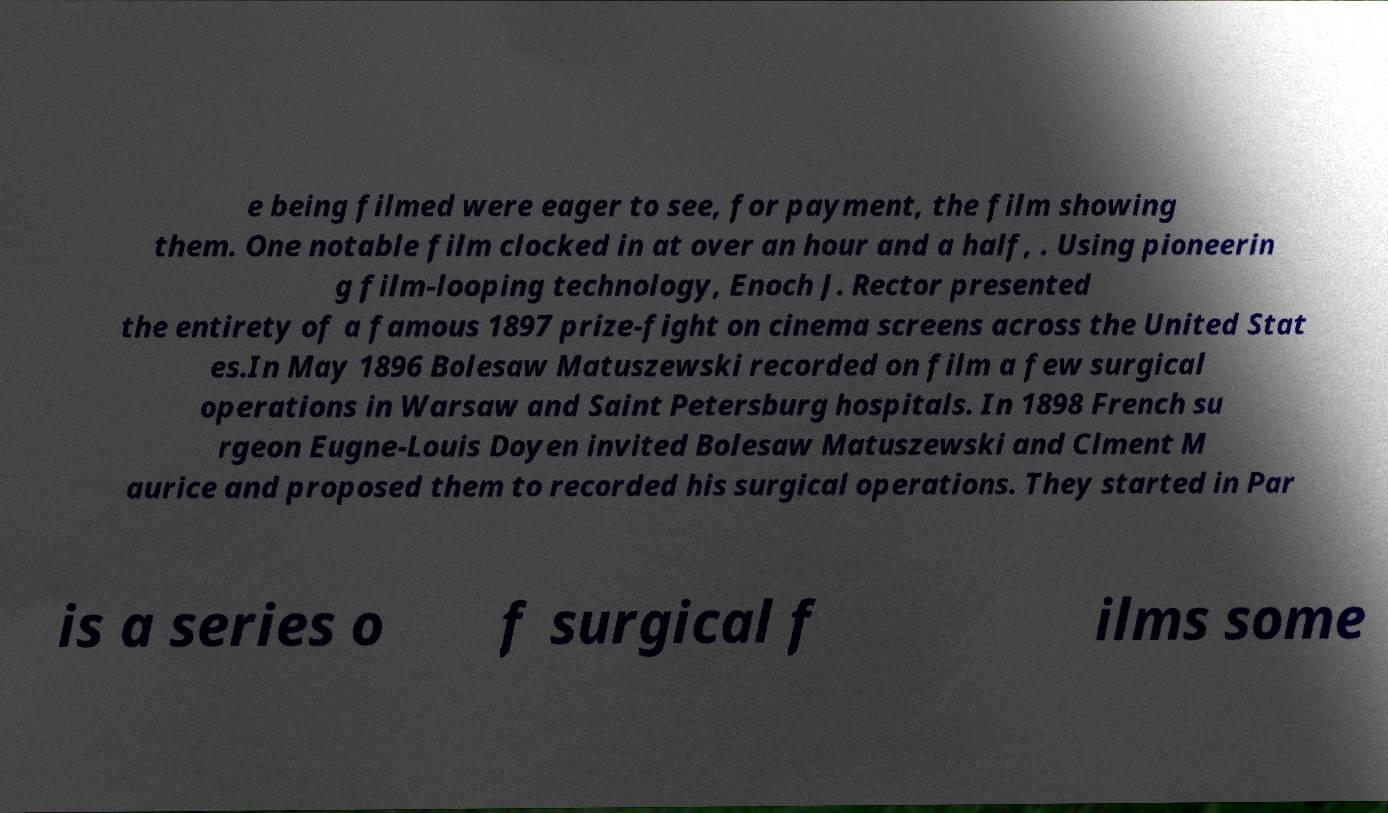What messages or text are displayed in this image? I need them in a readable, typed format. e being filmed were eager to see, for payment, the film showing them. One notable film clocked in at over an hour and a half, . Using pioneerin g film-looping technology, Enoch J. Rector presented the entirety of a famous 1897 prize-fight on cinema screens across the United Stat es.In May 1896 Bolesaw Matuszewski recorded on film a few surgical operations in Warsaw and Saint Petersburg hospitals. In 1898 French su rgeon Eugne-Louis Doyen invited Bolesaw Matuszewski and Clment M aurice and proposed them to recorded his surgical operations. They started in Par is a series o f surgical f ilms some 